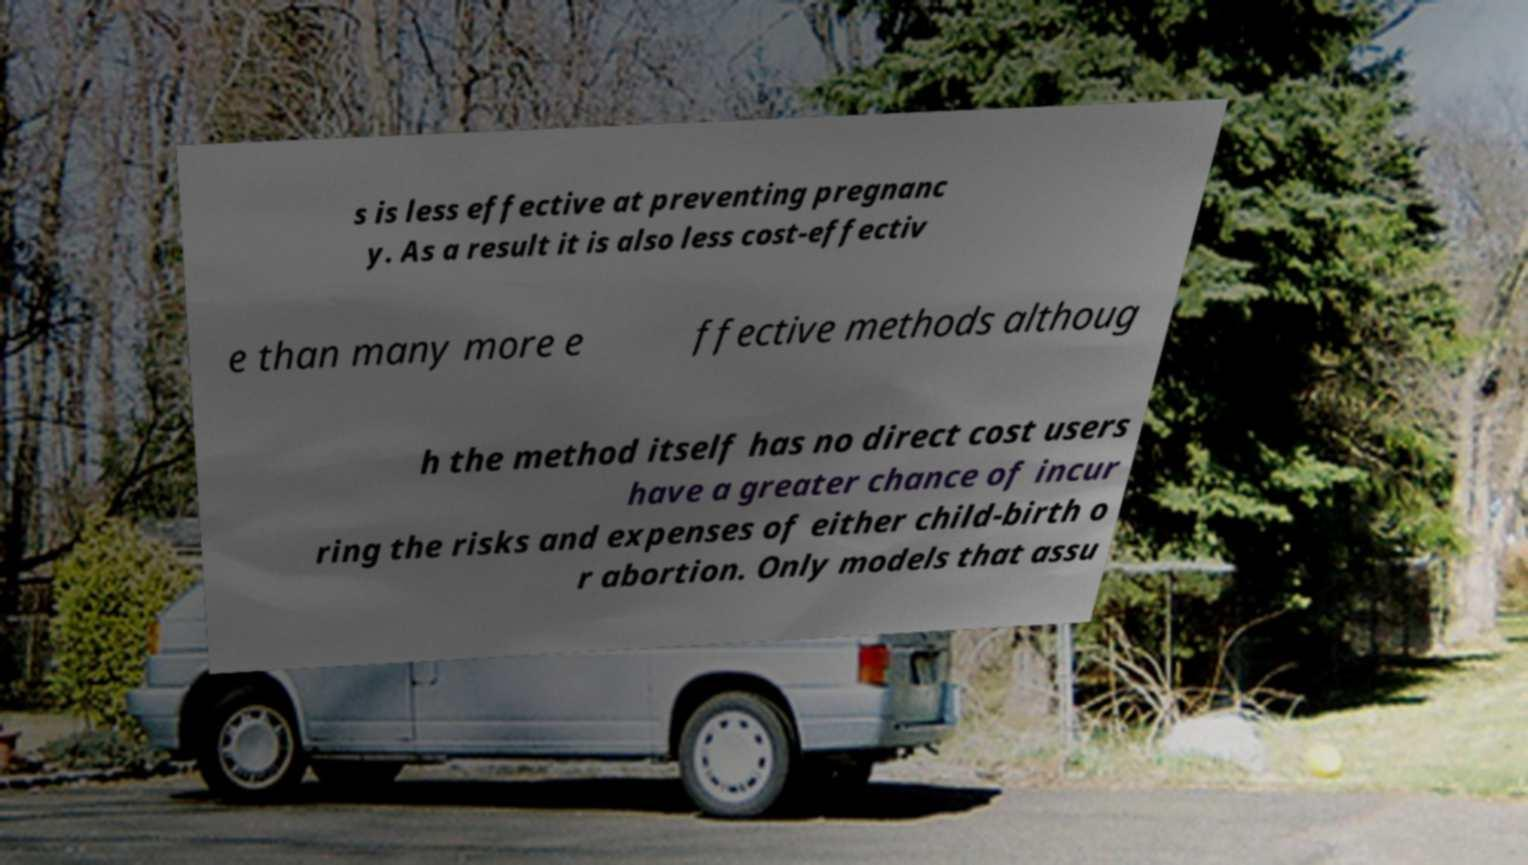Can you accurately transcribe the text from the provided image for me? s is less effective at preventing pregnanc y. As a result it is also less cost-effectiv e than many more e ffective methods althoug h the method itself has no direct cost users have a greater chance of incur ring the risks and expenses of either child-birth o r abortion. Only models that assu 